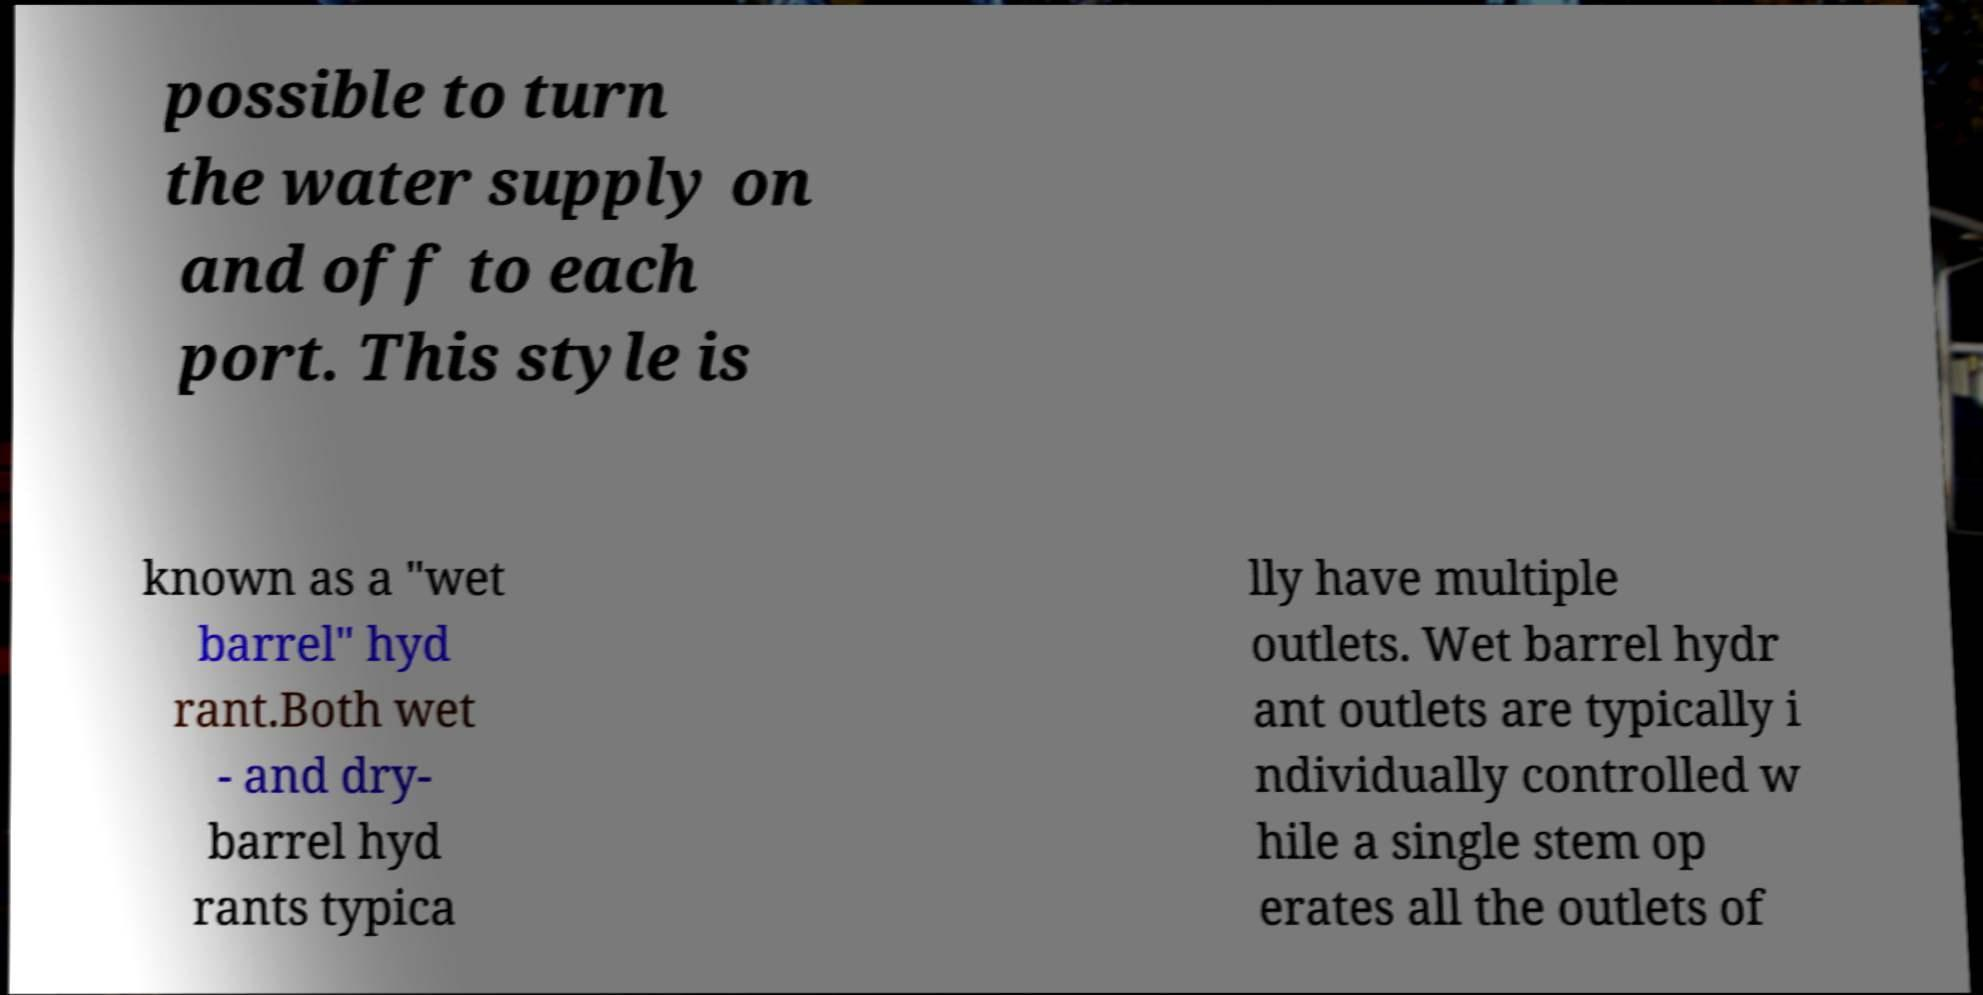Could you extract and type out the text from this image? possible to turn the water supply on and off to each port. This style is known as a "wet barrel" hyd rant.Both wet - and dry- barrel hyd rants typica lly have multiple outlets. Wet barrel hydr ant outlets are typically i ndividually controlled w hile a single stem op erates all the outlets of 